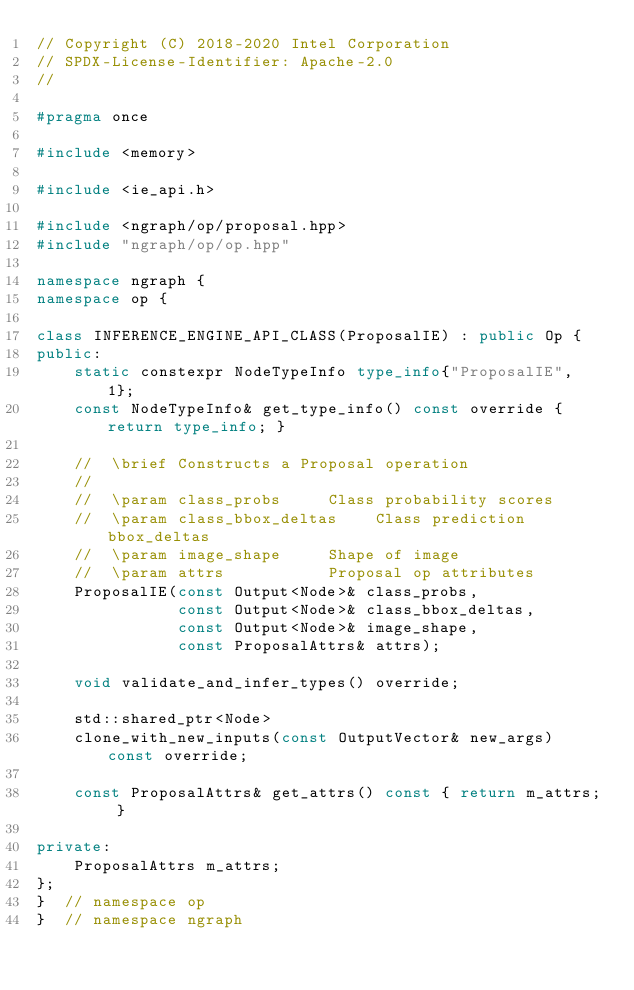Convert code to text. <code><loc_0><loc_0><loc_500><loc_500><_C++_>// Copyright (C) 2018-2020 Intel Corporation
// SPDX-License-Identifier: Apache-2.0
//

#pragma once

#include <memory>

#include <ie_api.h>

#include <ngraph/op/proposal.hpp>
#include "ngraph/op/op.hpp"

namespace ngraph {
namespace op {

class INFERENCE_ENGINE_API_CLASS(ProposalIE) : public Op {
public:
    static constexpr NodeTypeInfo type_info{"ProposalIE", 1};
    const NodeTypeInfo& get_type_info() const override { return type_info; }

    //  \brief Constructs a Proposal operation
    //
    //  \param class_probs     Class probability scores
    //  \param class_bbox_deltas    Class prediction bbox_deltas
    //  \param image_shape     Shape of image
    //  \param attrs           Proposal op attributes
    ProposalIE(const Output<Node>& class_probs,
               const Output<Node>& class_bbox_deltas,
               const Output<Node>& image_shape,
               const ProposalAttrs& attrs);

    void validate_and_infer_types() override;

    std::shared_ptr<Node>
    clone_with_new_inputs(const OutputVector& new_args) const override;

    const ProposalAttrs& get_attrs() const { return m_attrs; }

private:
    ProposalAttrs m_attrs;
};
}  // namespace op
}  // namespace ngraph
</code> 